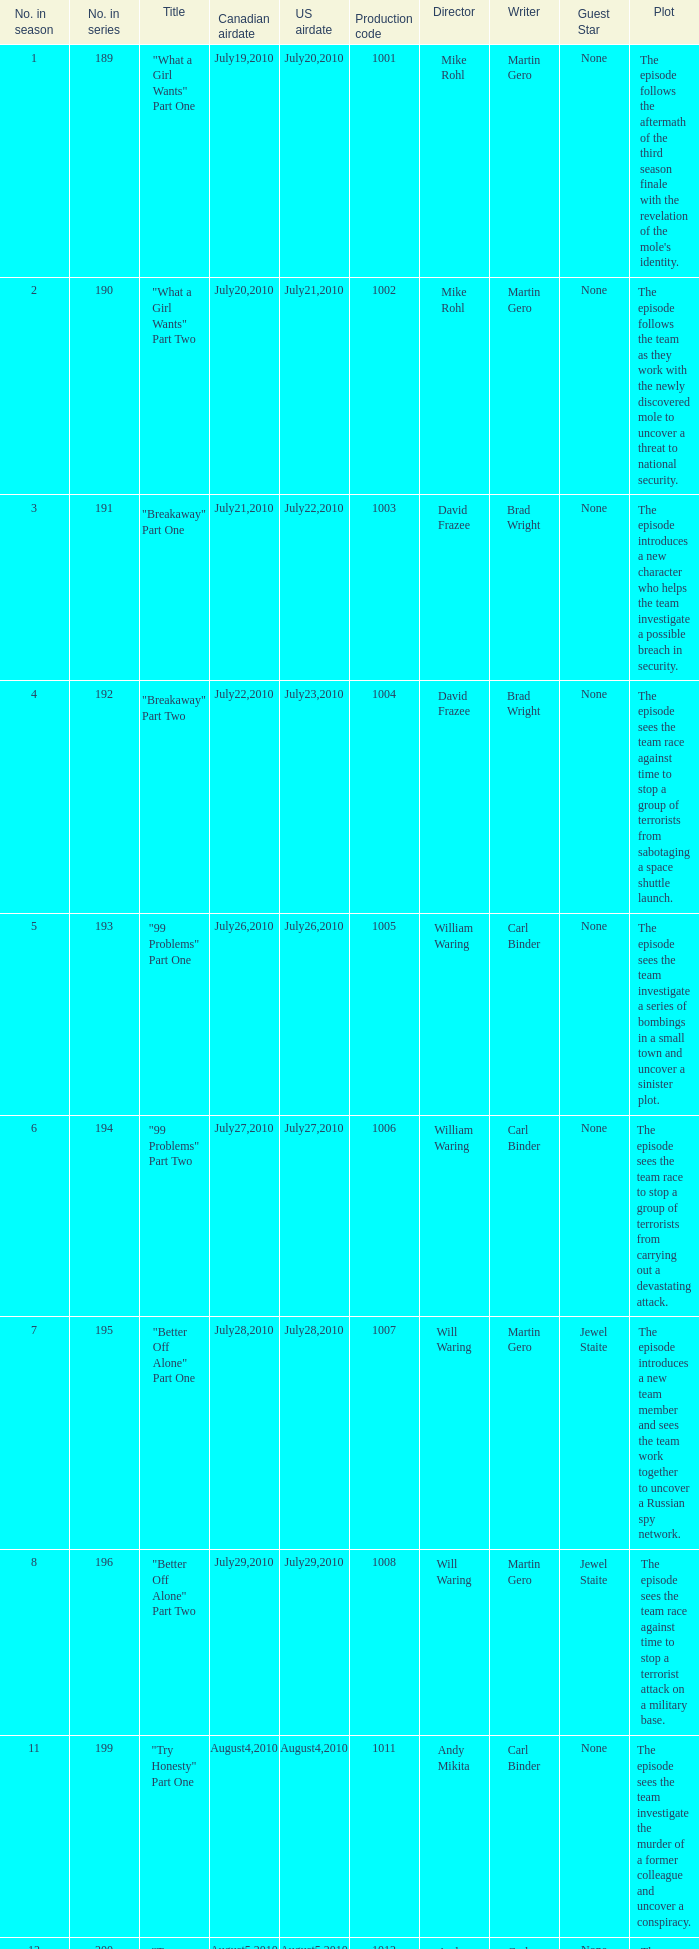What was the us airdate of "love lockdown" part one? October15,2010. 